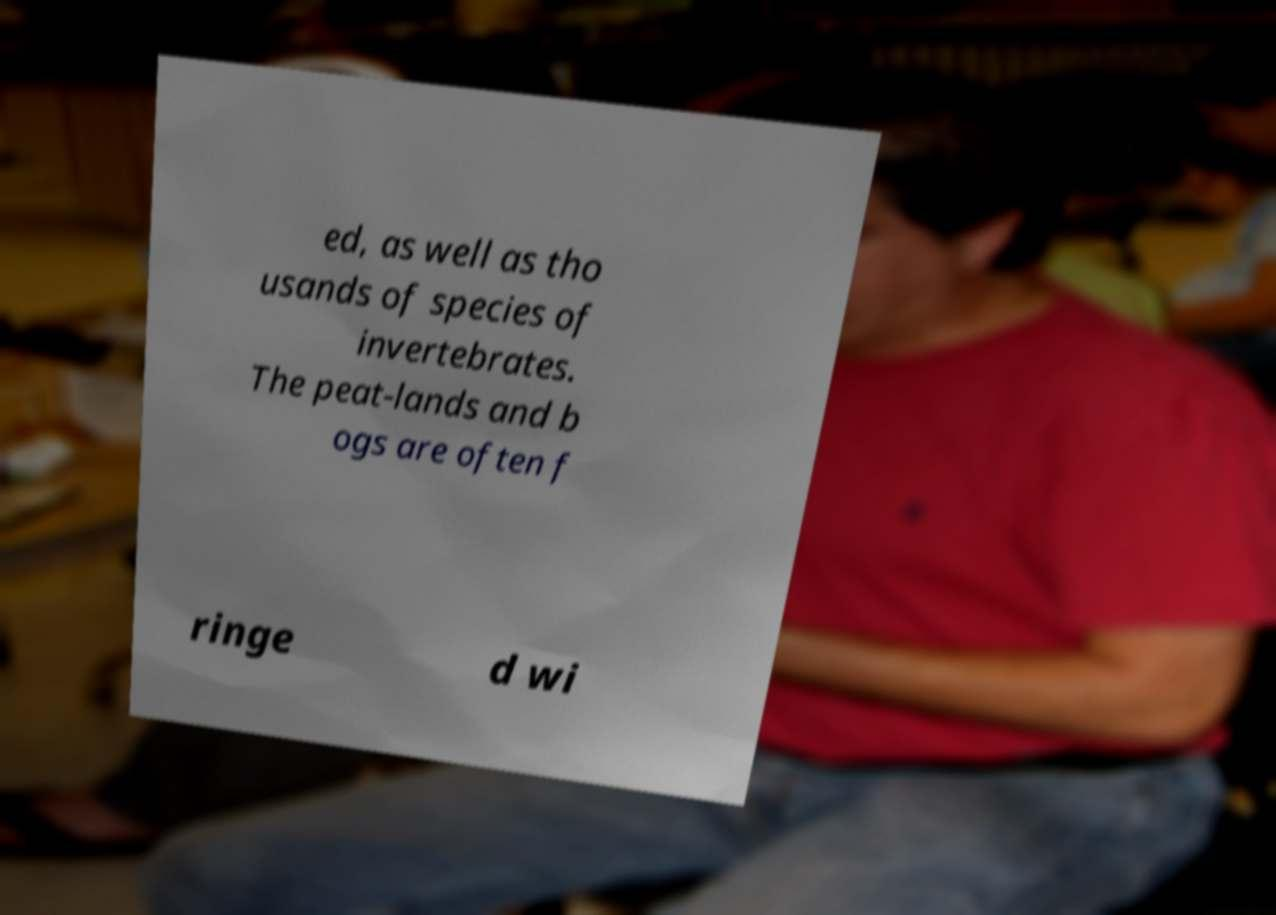Can you read and provide the text displayed in the image?This photo seems to have some interesting text. Can you extract and type it out for me? ed, as well as tho usands of species of invertebrates. The peat-lands and b ogs are often f ringe d wi 